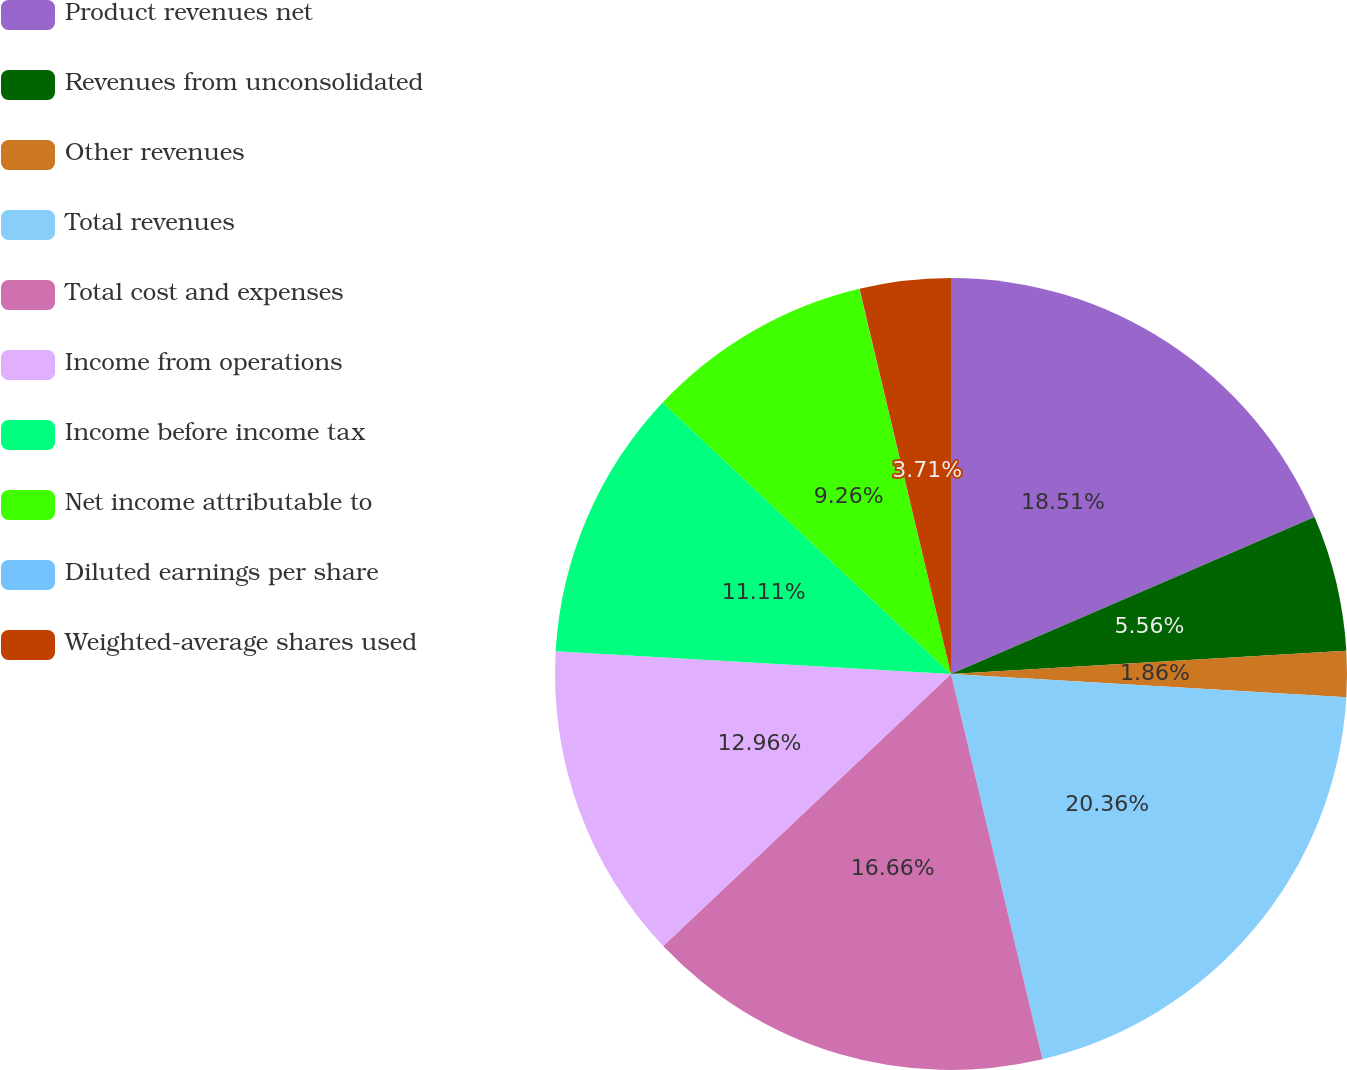Convert chart. <chart><loc_0><loc_0><loc_500><loc_500><pie_chart><fcel>Product revenues net<fcel>Revenues from unconsolidated<fcel>Other revenues<fcel>Total revenues<fcel>Total cost and expenses<fcel>Income from operations<fcel>Income before income tax<fcel>Net income attributable to<fcel>Diluted earnings per share<fcel>Weighted-average shares used<nl><fcel>18.51%<fcel>5.56%<fcel>1.86%<fcel>20.36%<fcel>16.66%<fcel>12.96%<fcel>11.11%<fcel>9.26%<fcel>0.01%<fcel>3.71%<nl></chart> 